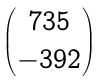<formula> <loc_0><loc_0><loc_500><loc_500>\begin{pmatrix} 7 3 5 \\ - 3 9 2 \end{pmatrix}</formula> 